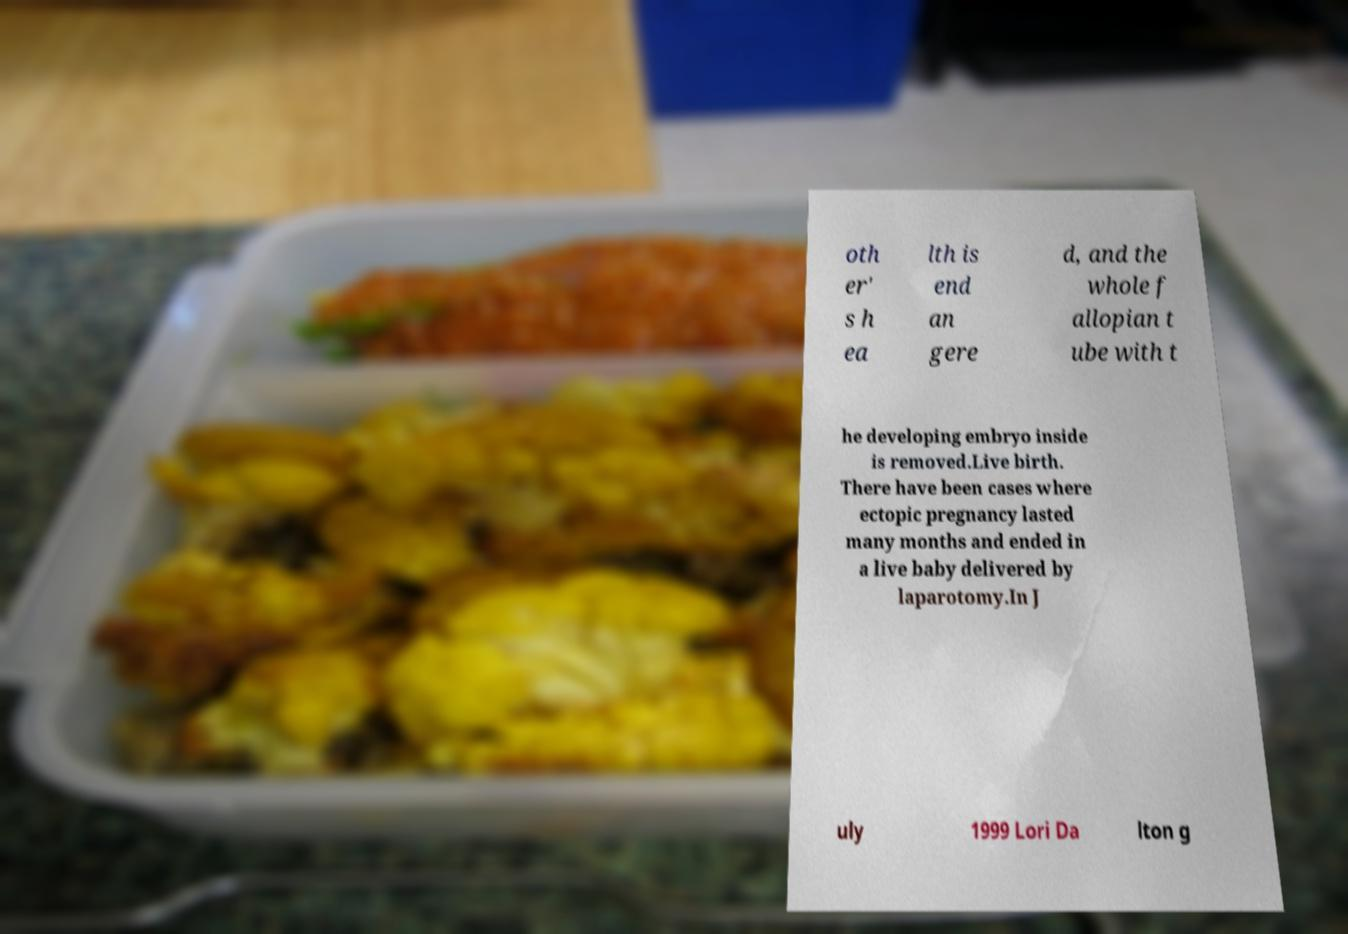What messages or text are displayed in this image? I need them in a readable, typed format. oth er' s h ea lth is end an gere d, and the whole f allopian t ube with t he developing embryo inside is removed.Live birth. There have been cases where ectopic pregnancy lasted many months and ended in a live baby delivered by laparotomy.In J uly 1999 Lori Da lton g 